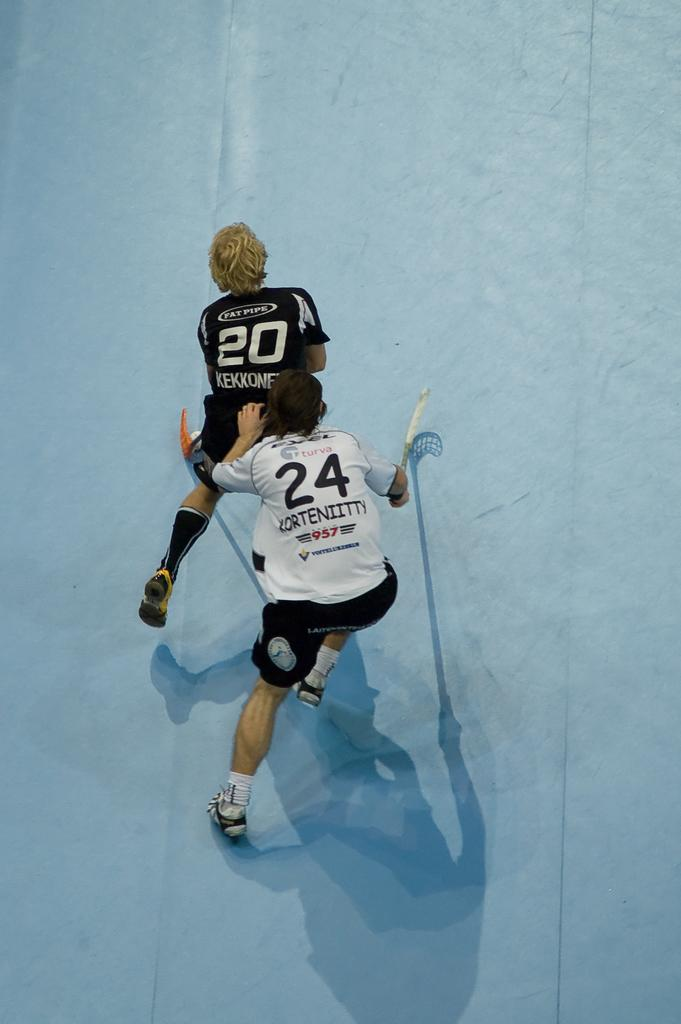<image>
Share a concise interpretation of the image provided. A female athlete with Fat Pipe on the back of her shirt is pursued by an opponent. 